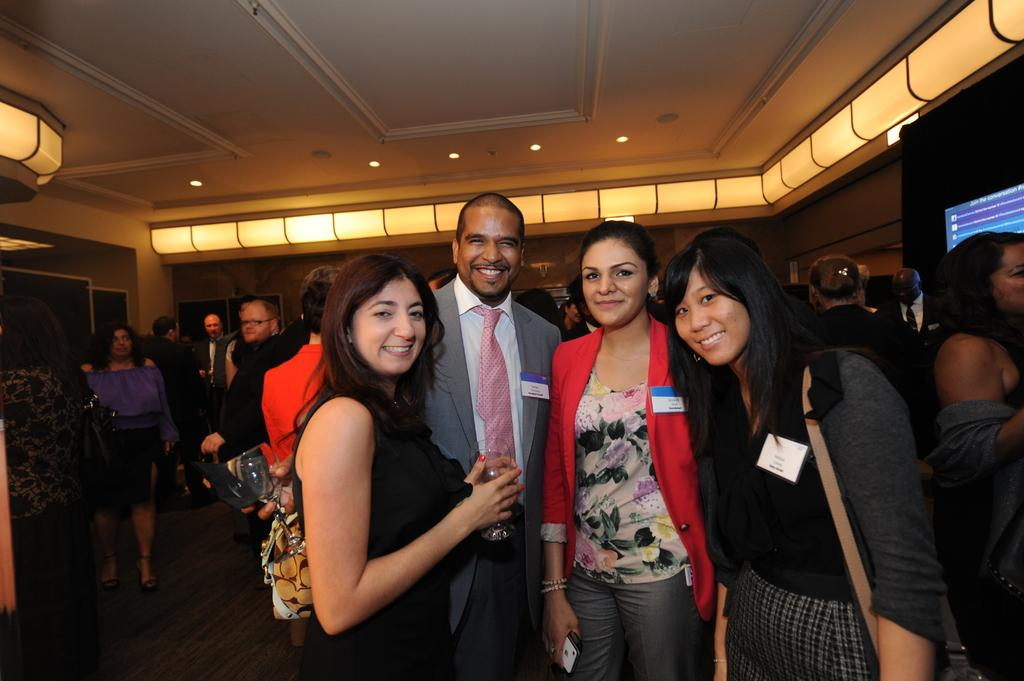How many people are in the image? There is a group of people in the image, but the exact number is not specified. What are the people in the image doing? The people are standing in the image. What can be seen in the background or surroundings of the people? There are lights visible in the image. What other objects or elements can be seen in the image besides the people? There are other objects present in the image, but their specific nature is not mentioned. What type of floor can be seen in the image? There is no information about the floor in the image, as the focus is on the group of people and the lights. 